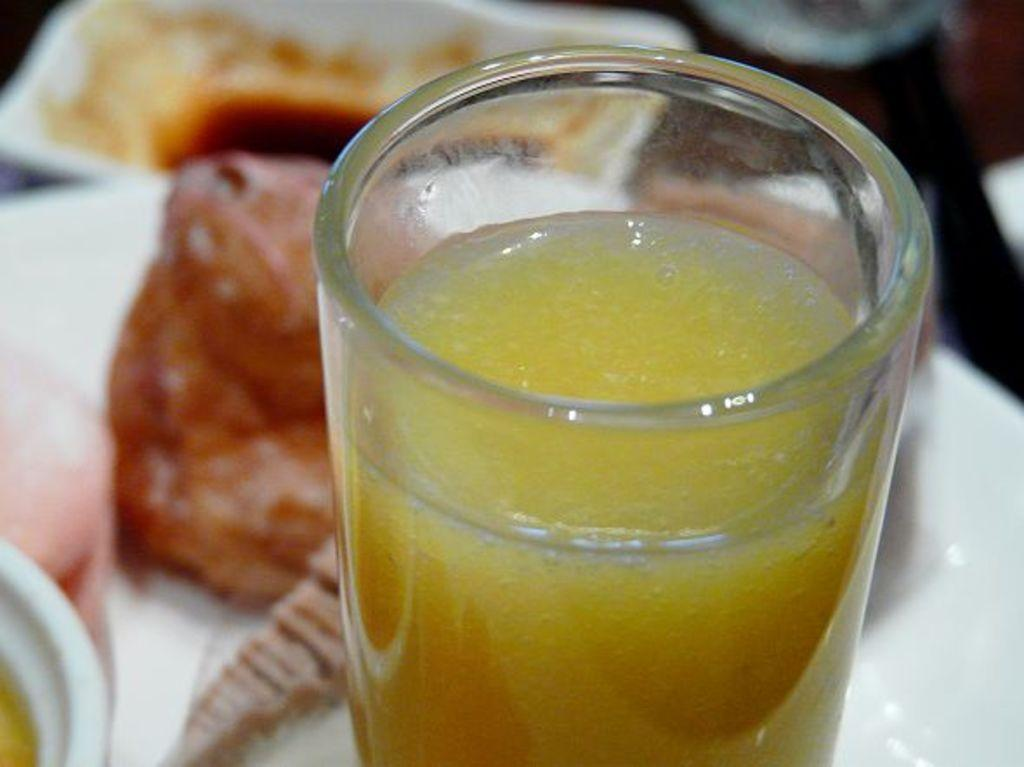What is in the glass that is visible in the image? There is a glass with juice in the image. Where is the glass located in the image? The glass is in the front of the image. What else can be seen in the image besides the glass? There is food visible in the background of the image. Is there a scene of a snake driving a car in the image? No, there is no scene of a snake driving a car in the image. 